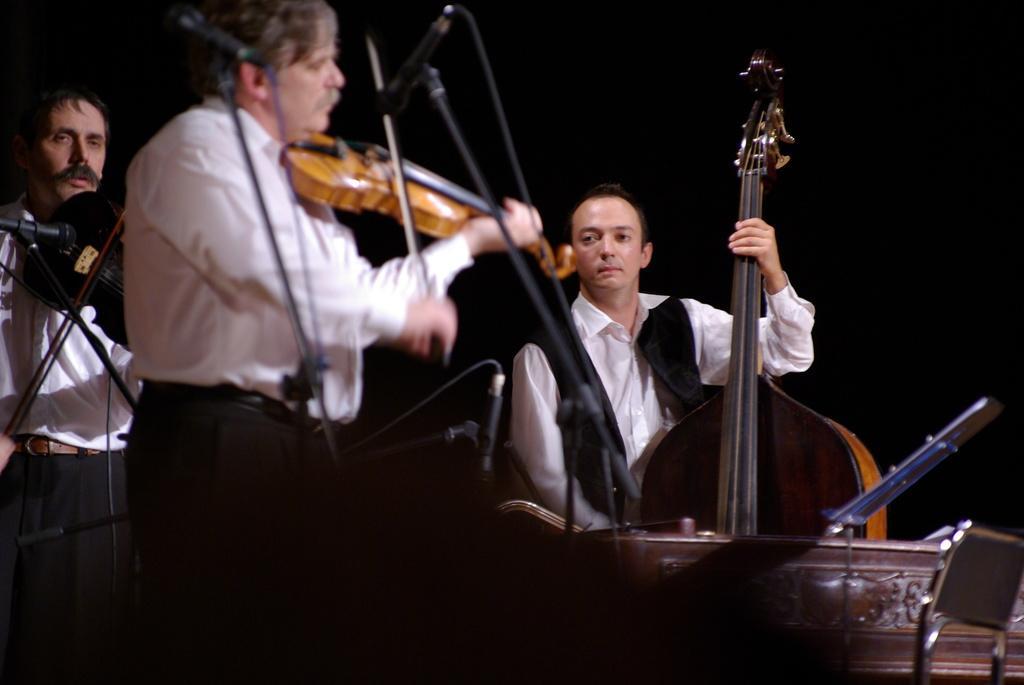How would you summarize this image in a sentence or two? This is a picture of a persons who are performing the music. The person is standing in a white shirt playing a violin. This is a microphone and the microphone stand and these are the other musical instrument the background of the person is black color. 